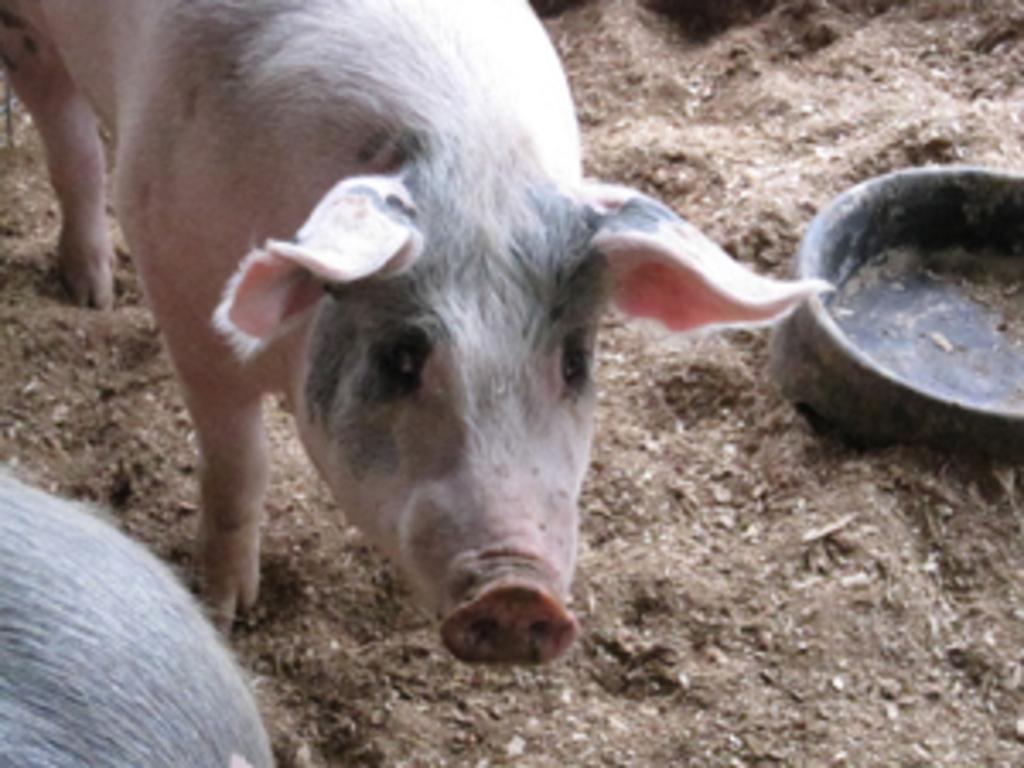How would you summarize this image in a sentence or two? In this picture we can see a pig standing on the path. There is a bowl on the right side. 